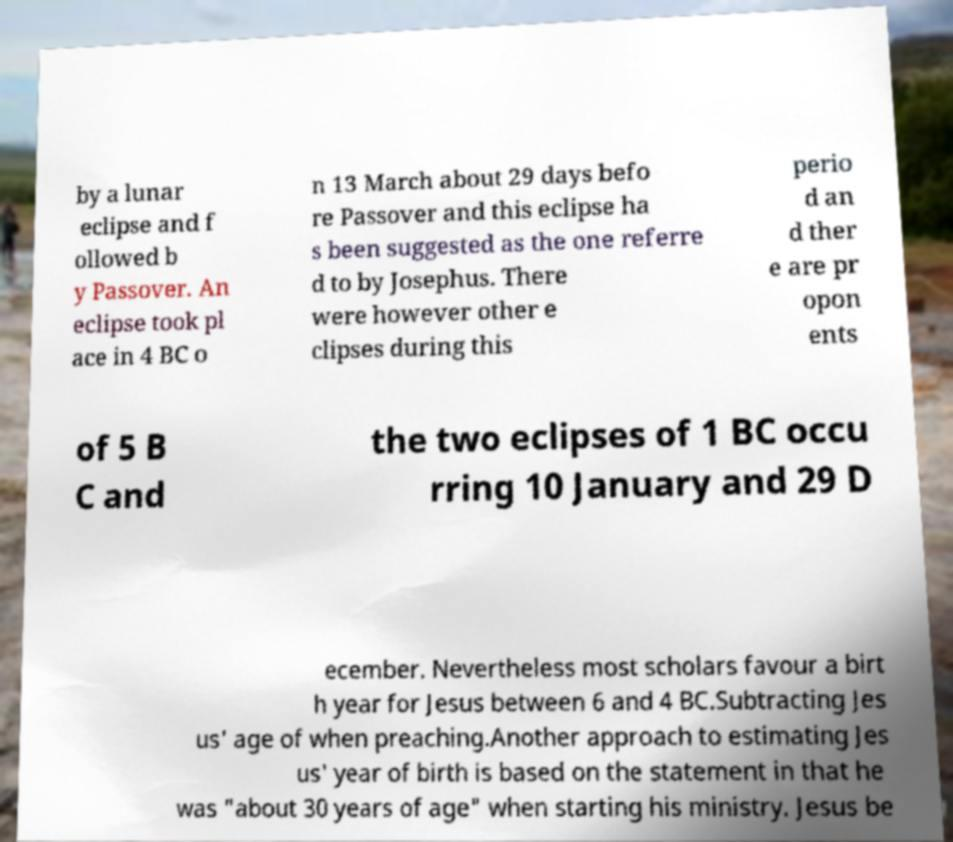Could you extract and type out the text from this image? by a lunar eclipse and f ollowed b y Passover. An eclipse took pl ace in 4 BC o n 13 March about 29 days befo re Passover and this eclipse ha s been suggested as the one referre d to by Josephus. There were however other e clipses during this perio d an d ther e are pr opon ents of 5 B C and the two eclipses of 1 BC occu rring 10 January and 29 D ecember. Nevertheless most scholars favour a birt h year for Jesus between 6 and 4 BC.Subtracting Jes us' age of when preaching.Another approach to estimating Jes us' year of birth is based on the statement in that he was "about 30 years of age" when starting his ministry. Jesus be 